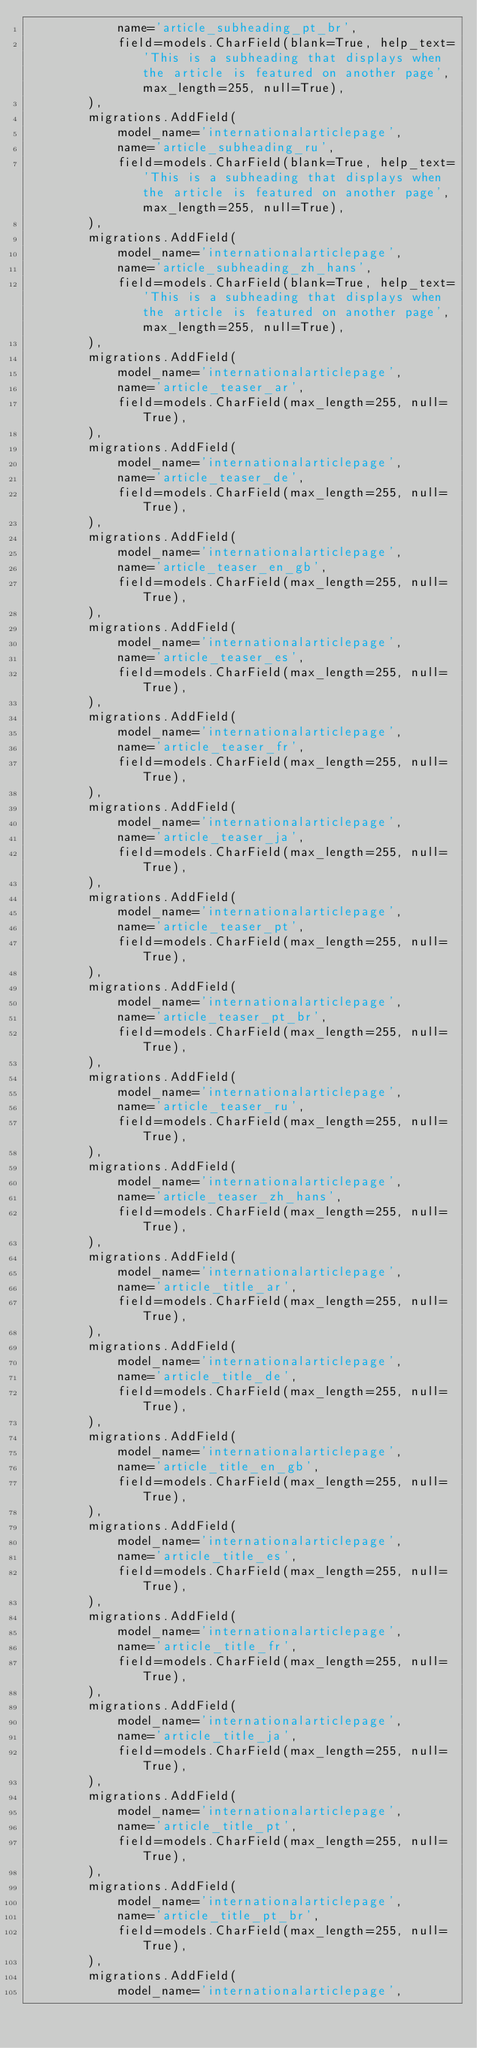Convert code to text. <code><loc_0><loc_0><loc_500><loc_500><_Python_>            name='article_subheading_pt_br',
            field=models.CharField(blank=True, help_text='This is a subheading that displays when the article is featured on another page', max_length=255, null=True),
        ),
        migrations.AddField(
            model_name='internationalarticlepage',
            name='article_subheading_ru',
            field=models.CharField(blank=True, help_text='This is a subheading that displays when the article is featured on another page', max_length=255, null=True),
        ),
        migrations.AddField(
            model_name='internationalarticlepage',
            name='article_subheading_zh_hans',
            field=models.CharField(blank=True, help_text='This is a subheading that displays when the article is featured on another page', max_length=255, null=True),
        ),
        migrations.AddField(
            model_name='internationalarticlepage',
            name='article_teaser_ar',
            field=models.CharField(max_length=255, null=True),
        ),
        migrations.AddField(
            model_name='internationalarticlepage',
            name='article_teaser_de',
            field=models.CharField(max_length=255, null=True),
        ),
        migrations.AddField(
            model_name='internationalarticlepage',
            name='article_teaser_en_gb',
            field=models.CharField(max_length=255, null=True),
        ),
        migrations.AddField(
            model_name='internationalarticlepage',
            name='article_teaser_es',
            field=models.CharField(max_length=255, null=True),
        ),
        migrations.AddField(
            model_name='internationalarticlepage',
            name='article_teaser_fr',
            field=models.CharField(max_length=255, null=True),
        ),
        migrations.AddField(
            model_name='internationalarticlepage',
            name='article_teaser_ja',
            field=models.CharField(max_length=255, null=True),
        ),
        migrations.AddField(
            model_name='internationalarticlepage',
            name='article_teaser_pt',
            field=models.CharField(max_length=255, null=True),
        ),
        migrations.AddField(
            model_name='internationalarticlepage',
            name='article_teaser_pt_br',
            field=models.CharField(max_length=255, null=True),
        ),
        migrations.AddField(
            model_name='internationalarticlepage',
            name='article_teaser_ru',
            field=models.CharField(max_length=255, null=True),
        ),
        migrations.AddField(
            model_name='internationalarticlepage',
            name='article_teaser_zh_hans',
            field=models.CharField(max_length=255, null=True),
        ),
        migrations.AddField(
            model_name='internationalarticlepage',
            name='article_title_ar',
            field=models.CharField(max_length=255, null=True),
        ),
        migrations.AddField(
            model_name='internationalarticlepage',
            name='article_title_de',
            field=models.CharField(max_length=255, null=True),
        ),
        migrations.AddField(
            model_name='internationalarticlepage',
            name='article_title_en_gb',
            field=models.CharField(max_length=255, null=True),
        ),
        migrations.AddField(
            model_name='internationalarticlepage',
            name='article_title_es',
            field=models.CharField(max_length=255, null=True),
        ),
        migrations.AddField(
            model_name='internationalarticlepage',
            name='article_title_fr',
            field=models.CharField(max_length=255, null=True),
        ),
        migrations.AddField(
            model_name='internationalarticlepage',
            name='article_title_ja',
            field=models.CharField(max_length=255, null=True),
        ),
        migrations.AddField(
            model_name='internationalarticlepage',
            name='article_title_pt',
            field=models.CharField(max_length=255, null=True),
        ),
        migrations.AddField(
            model_name='internationalarticlepage',
            name='article_title_pt_br',
            field=models.CharField(max_length=255, null=True),
        ),
        migrations.AddField(
            model_name='internationalarticlepage',</code> 